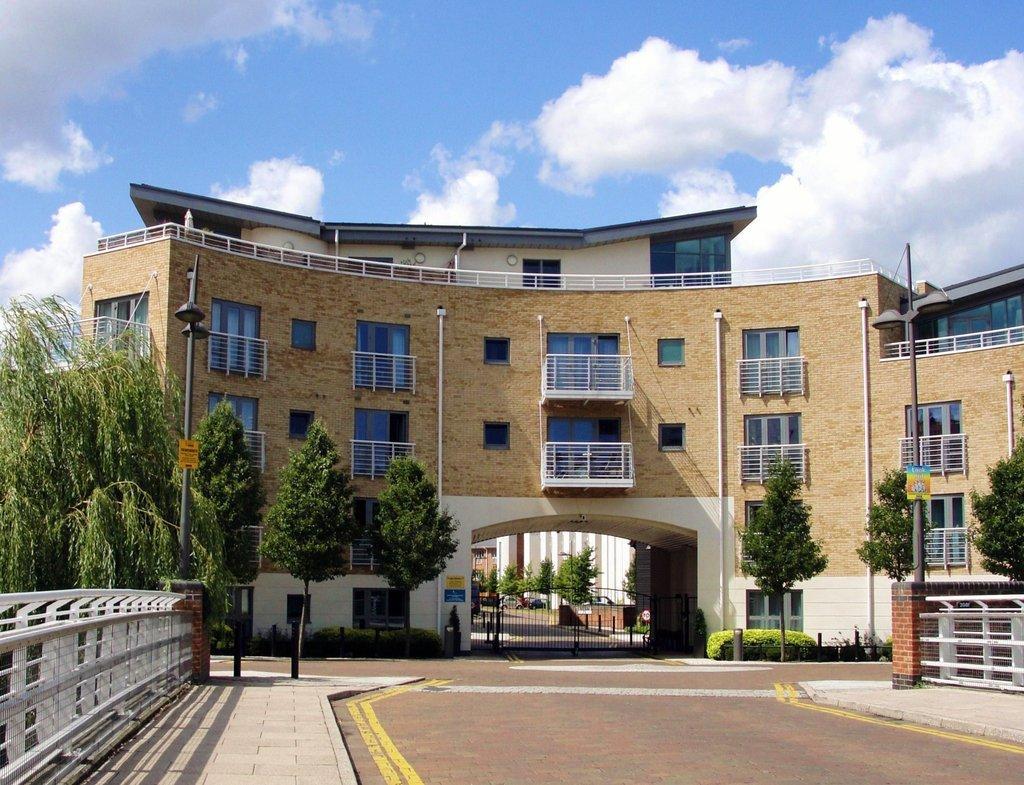In one or two sentences, can you explain what this image depicts? In this picture I can see the building. In front of the building I can see the trees, plants and poles. In the center I can see the gate. In the bottom left and bottom right I can see the fencing. At the top I can see the sky and clouds. 